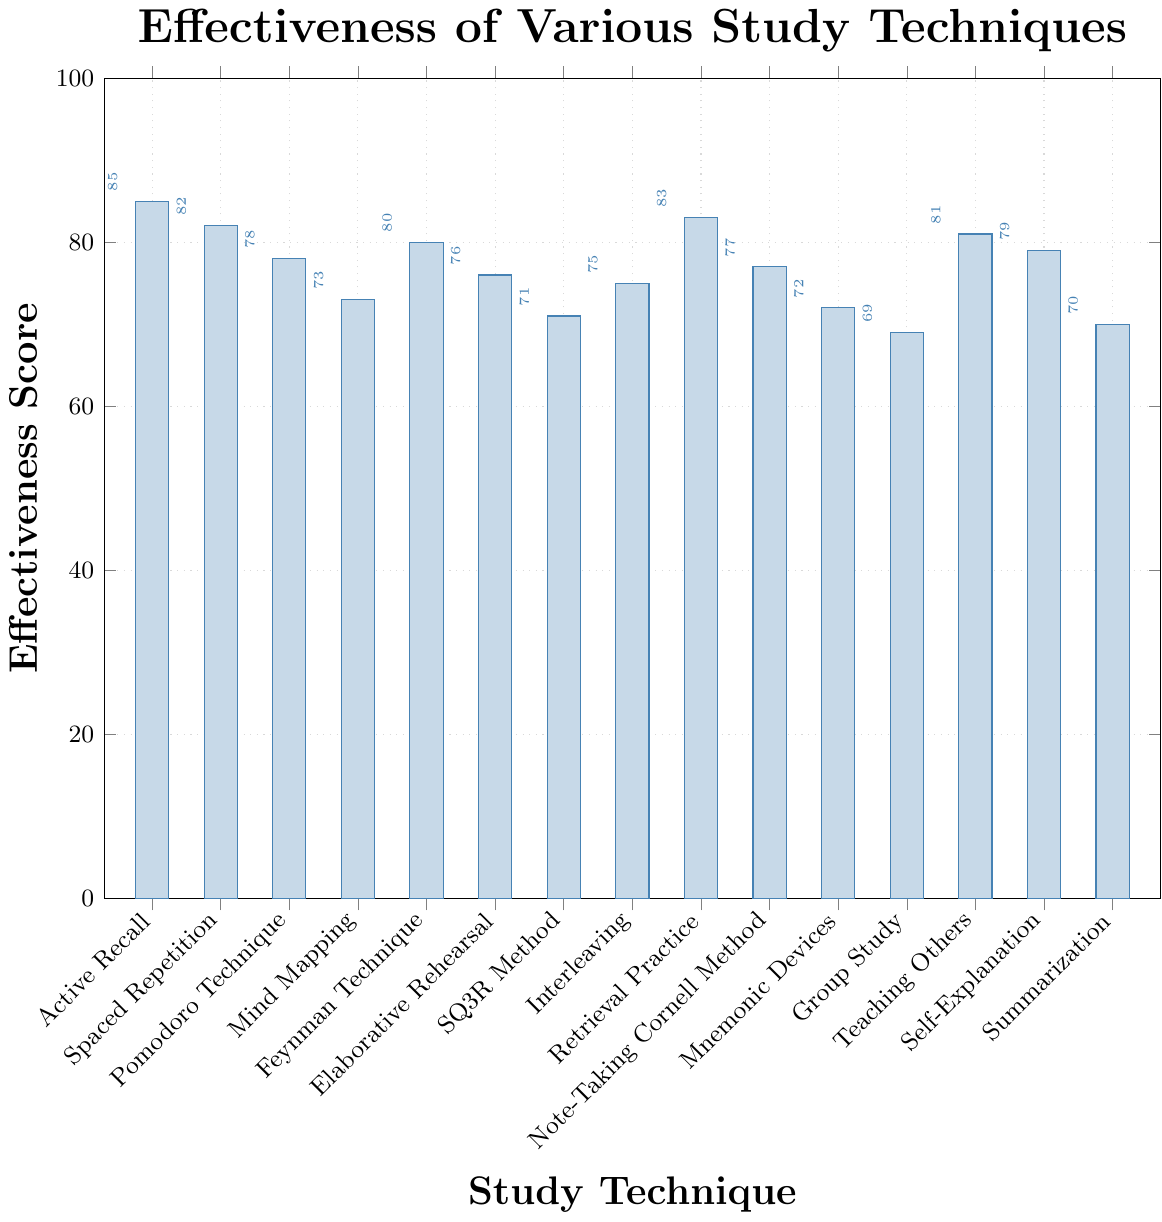What study technique has the highest effectiveness score? First, look at the height of all bars in the chart. The highest bar represents the technique with the highest score. According to the data, "Active Recall" has the highest bar with an effectiveness score of 85.
Answer: Active Recall Which study technique has the lowest effectiveness score? Check the shortest bar on the chart. The study technique represented by the shortest bar has the lowest effectiveness score. Based on the data, "Group Study" has the lowest score of 69.
Answer: Group Study What is the difference in effectiveness score between Active Recall and Group Study? To find the difference, subtract the effectiveness score of Group Study from that of Active Recall. Active Recall has a score of 85, and Group Study has a score of 69. So, 85 - 69 = 16.
Answer: 16 Are there any techniques with the same effectiveness score? Review the height of each bar. Since no two bars are the same height, this means there are no techniques with the same effectiveness score.
Answer: No What is the average effectiveness score of the techniques that score above 80? Identify techniques scoring above 80: Active Recall (85), Spaced Repetition (82), Retrieval Practice (83), Teaching Others (81). Sum their scores: 85 + 82 + 83 + 81 = 331. Divide by number of techniques: 331 / 4 = 82.75.
Answer: 82.75 Which technique has a higher score: Spaced Repetition or Pomodoro Technique? Compare the heights of the bars for Spaced Repetition and Pomodoro Technique. According to the chart, Spaced Repetition has a higher score (82) than Pomodoro Technique (78).
Answer: Spaced Repetition What is the effectiveness range of all the study techniques? The range is calculated by subtracting the lowest score from the highest score. The highest score is 85 (Active Recall) and the lowest is 69 (Group Study). Thus, the range is 85 - 69 = 16.
Answer: 16 How many study techniques have an effectiveness score less than 75? Count the bars that fall below the 75 mark. According to the data: Mind Mapping (73), Mnemonic Devices (72), SQ3R Method (71), Group Study (69), Summarization (70). This yields 5 techniques.
Answer: 5 Is Retrieval Practice more effective than Elaborative Rehearsal? Compare the heights of the bars for Retrieval Practice and Elaborative Rehearsal. Retrieval Practice has a higher score (83) than Elaborative Rehearsal (76).
Answer: Yes Which study technique is almost equally effective as Teaching Others? Find the bars close in height to Teaching Others (81). Feynman Technique and Self-Explanation are close with effectiveness scores of 80 and 79, respectively.
Answer: Feynman Technique and Self-Explanation 